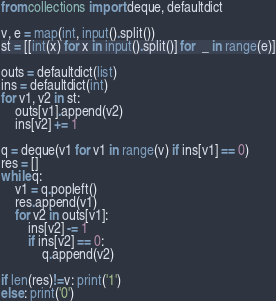Convert code to text. <code><loc_0><loc_0><loc_500><loc_500><_Python_>from collections import deque, defaultdict

v, e = map(int, input().split())
st = [[int(x) for x in input().split()] for  _ in range(e)]

outs = defaultdict(list)
ins = defaultdict(int)
for v1, v2 in st:
    outs[v1].append(v2)
    ins[v2] += 1

q = deque(v1 for v1 in range(v) if ins[v1] == 0)
res = []
while q:
    v1 = q.popleft()
    res.append(v1)
    for v2 in outs[v1]:
        ins[v2] -= 1
        if ins[v2] == 0:
            q.append(v2)

if len(res)!=v: print('1')
else: print('0')

</code> 